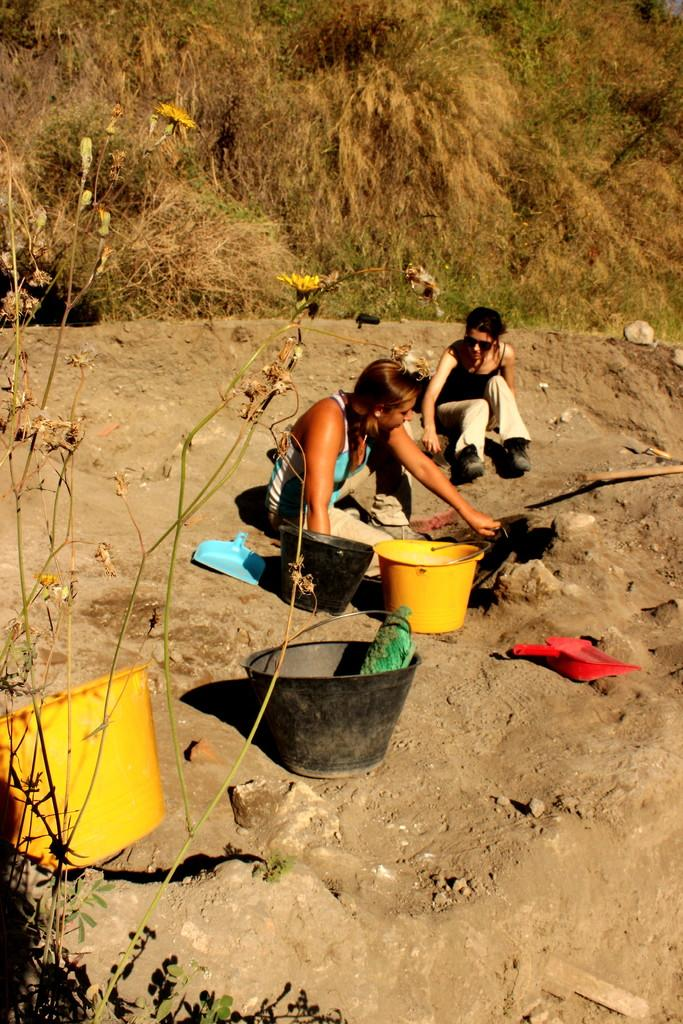What are the people in the image doing? The people in the image are sitting on the ground. What is the condition of the ground in the image? The ground in the image is muddy. What objects can be seen on the ground in the image? Buckets and baskets are visible on the ground in the image. What can be seen in the background of the image? Dry plants are visible in the background of the image. What type of apparel is the rat wearing in the image? There is no rat present in the image, so it is not possible to determine what type of apparel it might be wearing. 